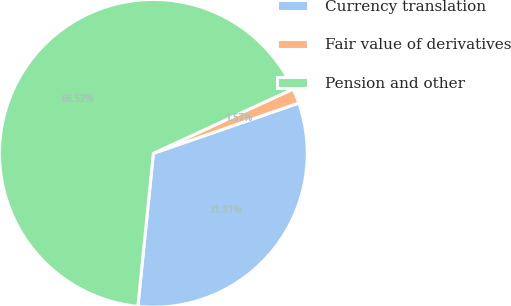Convert chart to OTSL. <chart><loc_0><loc_0><loc_500><loc_500><pie_chart><fcel>Currency translation<fcel>Fair value of derivatives<fcel>Pension and other<nl><fcel>31.91%<fcel>1.57%<fcel>66.52%<nl></chart> 